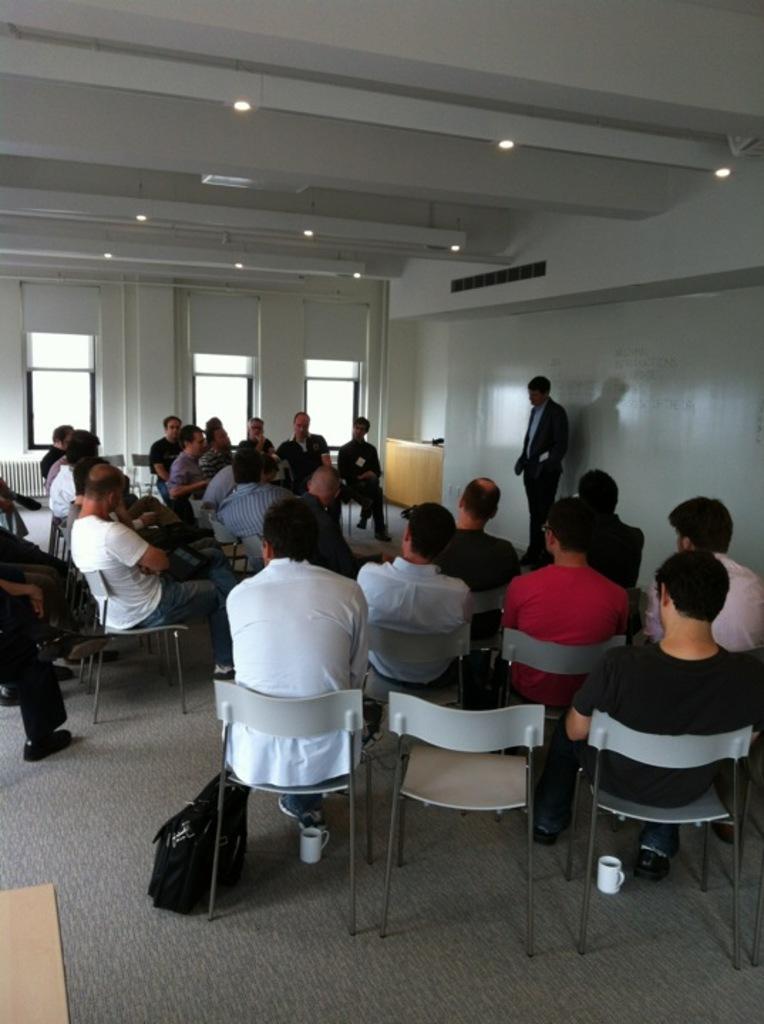In one or two sentences, can you explain what this image depicts? In this image I can see the group[ of people sitting on the chairs. There is a bag and cups on the floor. To the right there is a person standing and he is wearing the blazer. And there is a wall behind him. In the back there is a window and in the top there are lights. 